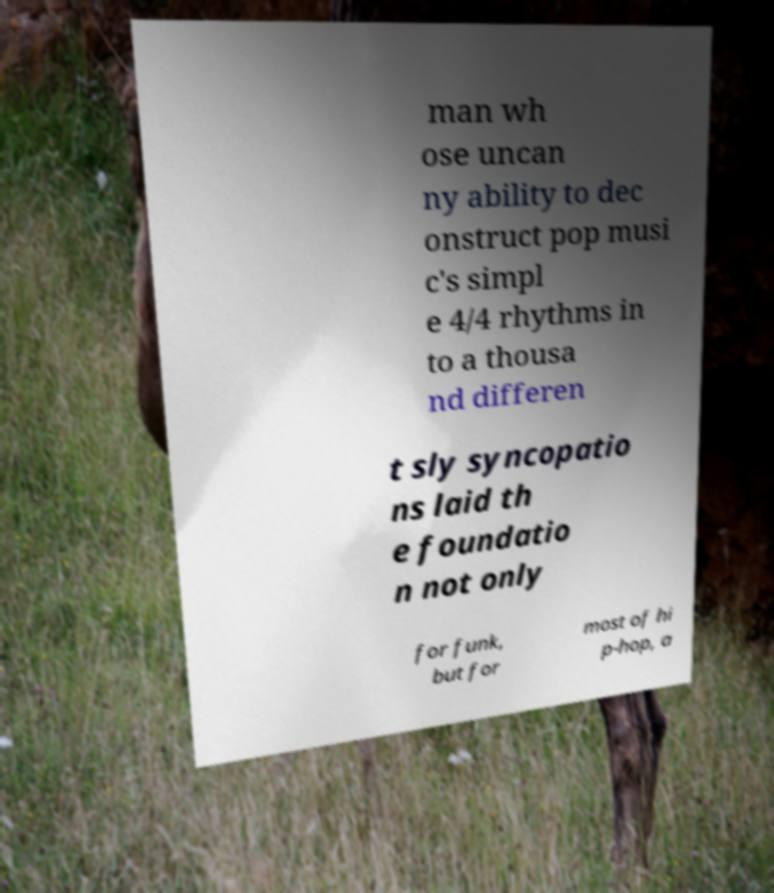Could you extract and type out the text from this image? man wh ose uncan ny ability to dec onstruct pop musi c's simpl e 4/4 rhythms in to a thousa nd differen t sly syncopatio ns laid th e foundatio n not only for funk, but for most of hi p-hop, a 